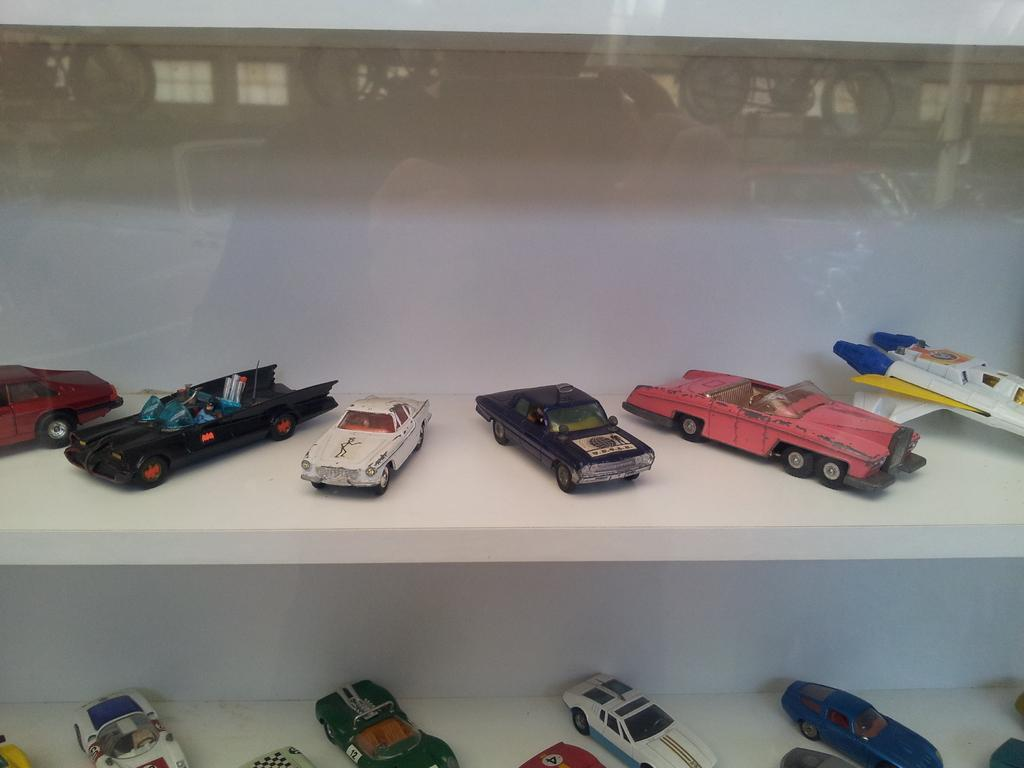What type of objects are stored on the shelf in the image? There are toy vehicles in a shelf in the image. What can be seen in the reflection of the image? There is a reflection of bicycles and a person in the image. What type of orange fruit can be seen hanging from the chain in the image? There is no orange fruit or chain present in the image. 